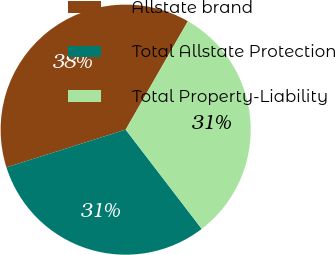Convert chart to OTSL. <chart><loc_0><loc_0><loc_500><loc_500><pie_chart><fcel>Allstate brand<fcel>Total Allstate Protection<fcel>Total Property-Liability<nl><fcel>38.17%<fcel>30.53%<fcel>31.3%<nl></chart> 